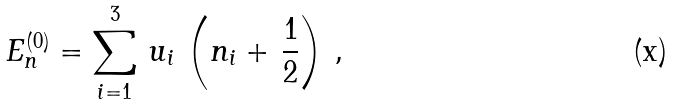<formula> <loc_0><loc_0><loc_500><loc_500>E _ { n } ^ { ( 0 ) } = \sum _ { i = 1 } ^ { 3 } \, u _ { i } \, \left ( n _ { i } + \, \frac { 1 } { 2 } \right ) \, ,</formula> 